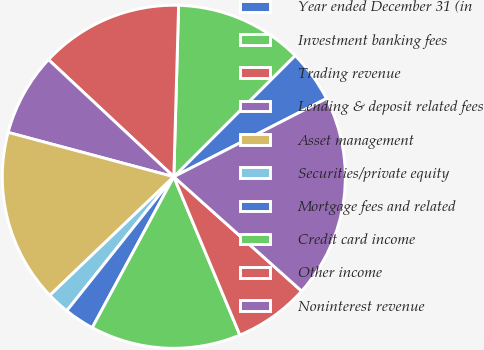Convert chart to OTSL. <chart><loc_0><loc_0><loc_500><loc_500><pie_chart><fcel>Year ended December 31 (in<fcel>Investment banking fees<fcel>Trading revenue<fcel>Lending & deposit related fees<fcel>Asset management<fcel>Securities/private equity<fcel>Mortgage fees and related<fcel>Credit card income<fcel>Other income<fcel>Noninterest revenue<nl><fcel>4.96%<fcel>12.06%<fcel>13.48%<fcel>7.8%<fcel>16.31%<fcel>2.13%<fcel>2.84%<fcel>14.18%<fcel>7.09%<fcel>19.15%<nl></chart> 